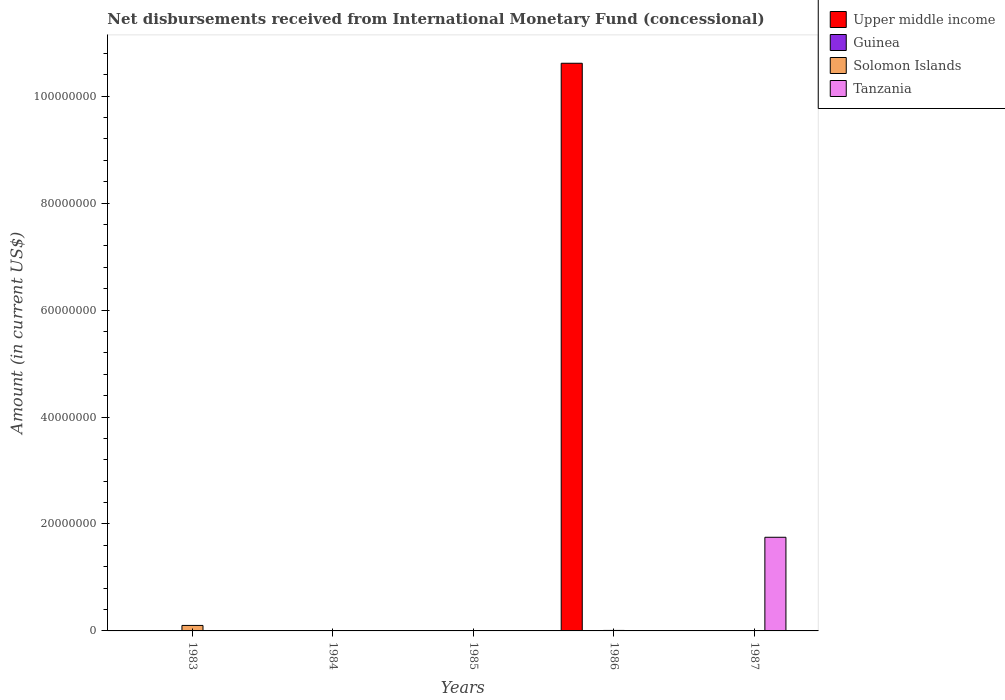How many different coloured bars are there?
Your response must be concise. 3. Are the number of bars on each tick of the X-axis equal?
Give a very brief answer. No. In how many cases, is the number of bars for a given year not equal to the number of legend labels?
Make the answer very short. 5. What is the amount of disbursements received from International Monetary Fund in Guinea in 1983?
Ensure brevity in your answer.  0. Across all years, what is the maximum amount of disbursements received from International Monetary Fund in Tanzania?
Offer a very short reply. 1.75e+07. In which year was the amount of disbursements received from International Monetary Fund in Solomon Islands maximum?
Keep it short and to the point. 1983. What is the average amount of disbursements received from International Monetary Fund in Tanzania per year?
Keep it short and to the point. 3.50e+06. What is the difference between the highest and the lowest amount of disbursements received from International Monetary Fund in Tanzania?
Your answer should be compact. 1.75e+07. In how many years, is the amount of disbursements received from International Monetary Fund in Upper middle income greater than the average amount of disbursements received from International Monetary Fund in Upper middle income taken over all years?
Your answer should be very brief. 1. How many years are there in the graph?
Make the answer very short. 5. Are the values on the major ticks of Y-axis written in scientific E-notation?
Offer a very short reply. No. Does the graph contain grids?
Provide a succinct answer. No. Where does the legend appear in the graph?
Offer a very short reply. Top right. How are the legend labels stacked?
Give a very brief answer. Vertical. What is the title of the graph?
Offer a very short reply. Net disbursements received from International Monetary Fund (concessional). What is the label or title of the Y-axis?
Offer a very short reply. Amount (in current US$). What is the Amount (in current US$) of Solomon Islands in 1983?
Keep it short and to the point. 1.03e+06. What is the Amount (in current US$) of Guinea in 1984?
Offer a terse response. 0. What is the Amount (in current US$) in Solomon Islands in 1984?
Your answer should be compact. 0. What is the Amount (in current US$) in Tanzania in 1984?
Give a very brief answer. 0. What is the Amount (in current US$) of Solomon Islands in 1985?
Keep it short and to the point. 0. What is the Amount (in current US$) in Upper middle income in 1986?
Offer a very short reply. 1.06e+08. What is the Amount (in current US$) in Guinea in 1986?
Keep it short and to the point. 0. What is the Amount (in current US$) of Solomon Islands in 1986?
Provide a short and direct response. 9.10e+04. What is the Amount (in current US$) in Upper middle income in 1987?
Provide a short and direct response. 0. What is the Amount (in current US$) in Guinea in 1987?
Your answer should be compact. 0. What is the Amount (in current US$) in Tanzania in 1987?
Offer a very short reply. 1.75e+07. Across all years, what is the maximum Amount (in current US$) in Upper middle income?
Offer a very short reply. 1.06e+08. Across all years, what is the maximum Amount (in current US$) in Solomon Islands?
Your answer should be compact. 1.03e+06. Across all years, what is the maximum Amount (in current US$) of Tanzania?
Make the answer very short. 1.75e+07. Across all years, what is the minimum Amount (in current US$) of Upper middle income?
Offer a very short reply. 0. Across all years, what is the minimum Amount (in current US$) of Tanzania?
Your answer should be very brief. 0. What is the total Amount (in current US$) of Upper middle income in the graph?
Ensure brevity in your answer.  1.06e+08. What is the total Amount (in current US$) of Guinea in the graph?
Give a very brief answer. 0. What is the total Amount (in current US$) in Solomon Islands in the graph?
Ensure brevity in your answer.  1.12e+06. What is the total Amount (in current US$) of Tanzania in the graph?
Offer a very short reply. 1.75e+07. What is the difference between the Amount (in current US$) of Solomon Islands in 1983 and that in 1986?
Offer a terse response. 9.35e+05. What is the difference between the Amount (in current US$) in Solomon Islands in 1983 and the Amount (in current US$) in Tanzania in 1987?
Your response must be concise. -1.65e+07. What is the difference between the Amount (in current US$) of Upper middle income in 1986 and the Amount (in current US$) of Tanzania in 1987?
Provide a short and direct response. 8.86e+07. What is the difference between the Amount (in current US$) in Solomon Islands in 1986 and the Amount (in current US$) in Tanzania in 1987?
Your response must be concise. -1.74e+07. What is the average Amount (in current US$) of Upper middle income per year?
Provide a succinct answer. 2.12e+07. What is the average Amount (in current US$) in Guinea per year?
Your response must be concise. 0. What is the average Amount (in current US$) in Solomon Islands per year?
Give a very brief answer. 2.23e+05. What is the average Amount (in current US$) in Tanzania per year?
Give a very brief answer. 3.50e+06. In the year 1986, what is the difference between the Amount (in current US$) of Upper middle income and Amount (in current US$) of Solomon Islands?
Offer a very short reply. 1.06e+08. What is the ratio of the Amount (in current US$) of Solomon Islands in 1983 to that in 1986?
Your answer should be compact. 11.27. What is the difference between the highest and the lowest Amount (in current US$) in Upper middle income?
Ensure brevity in your answer.  1.06e+08. What is the difference between the highest and the lowest Amount (in current US$) of Solomon Islands?
Your answer should be compact. 1.03e+06. What is the difference between the highest and the lowest Amount (in current US$) of Tanzania?
Your response must be concise. 1.75e+07. 